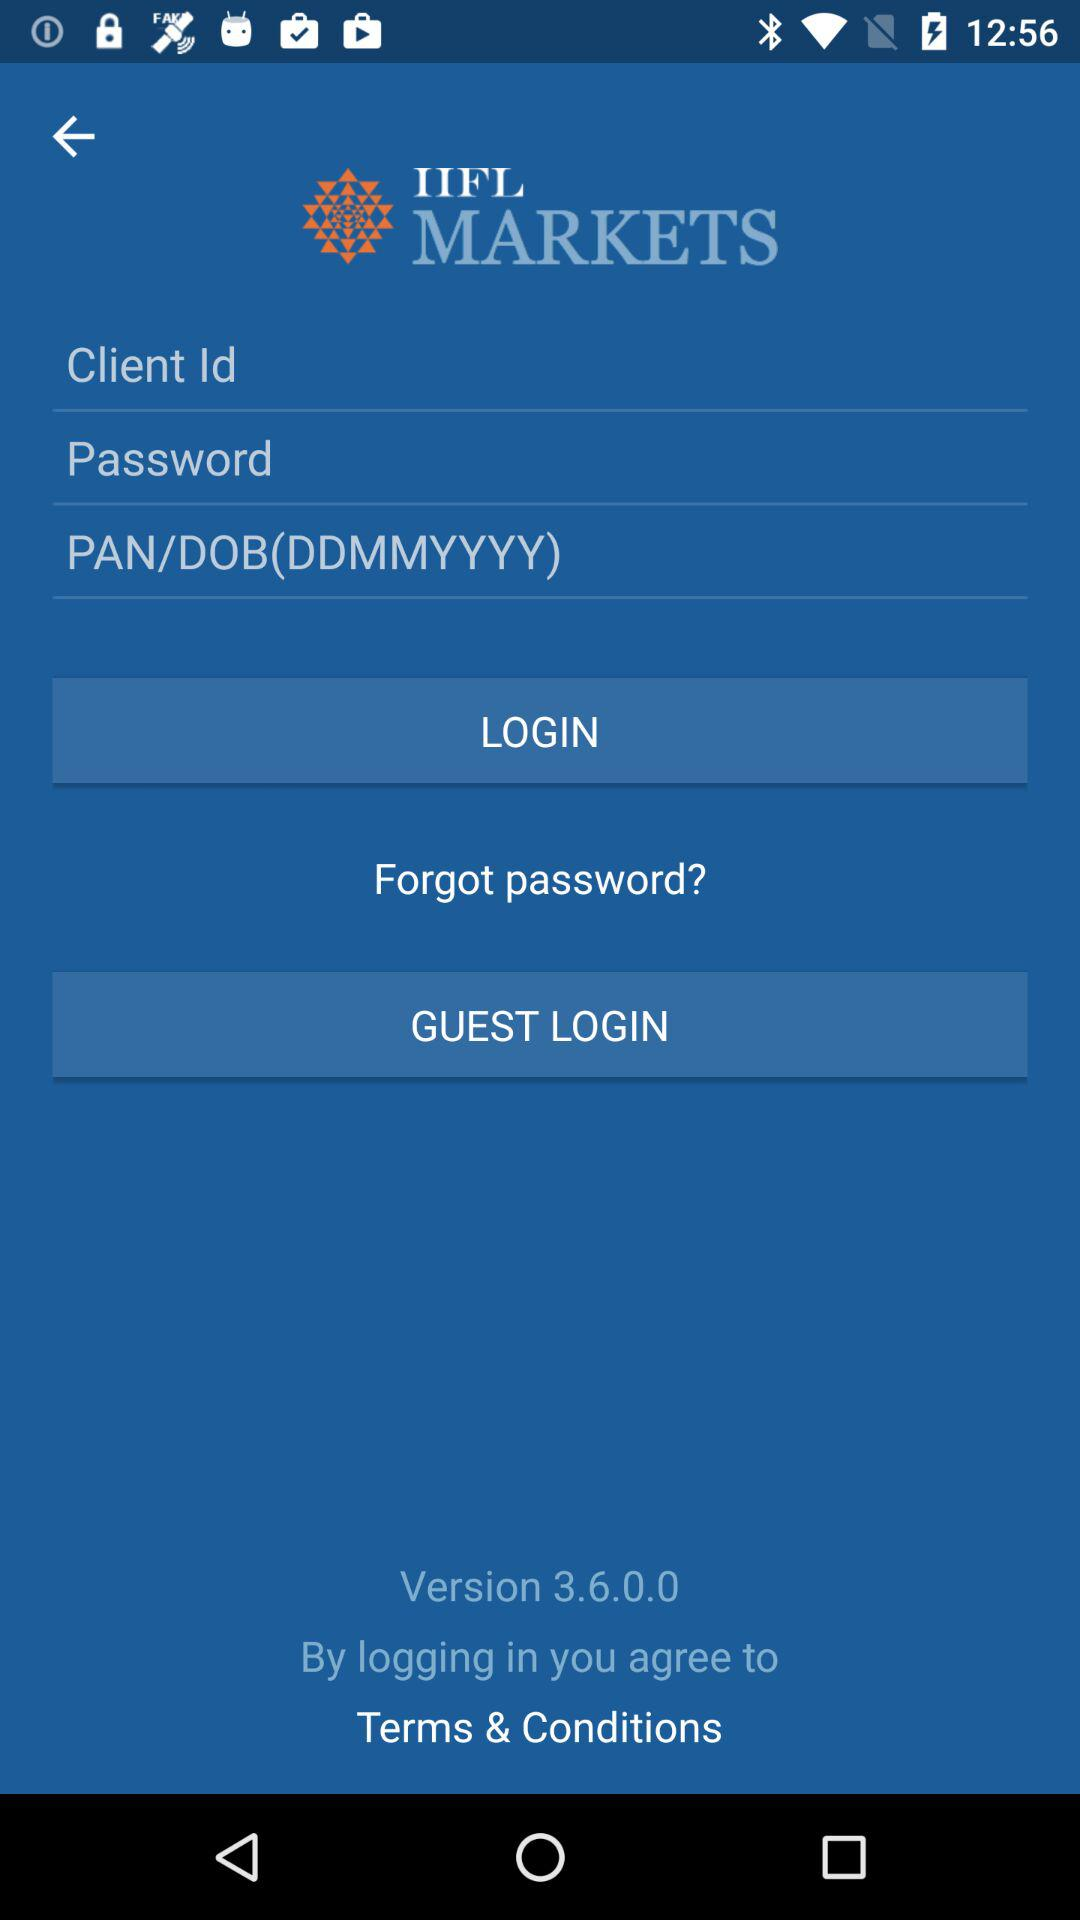What is the version number? The version number is 3.6.0.0. 